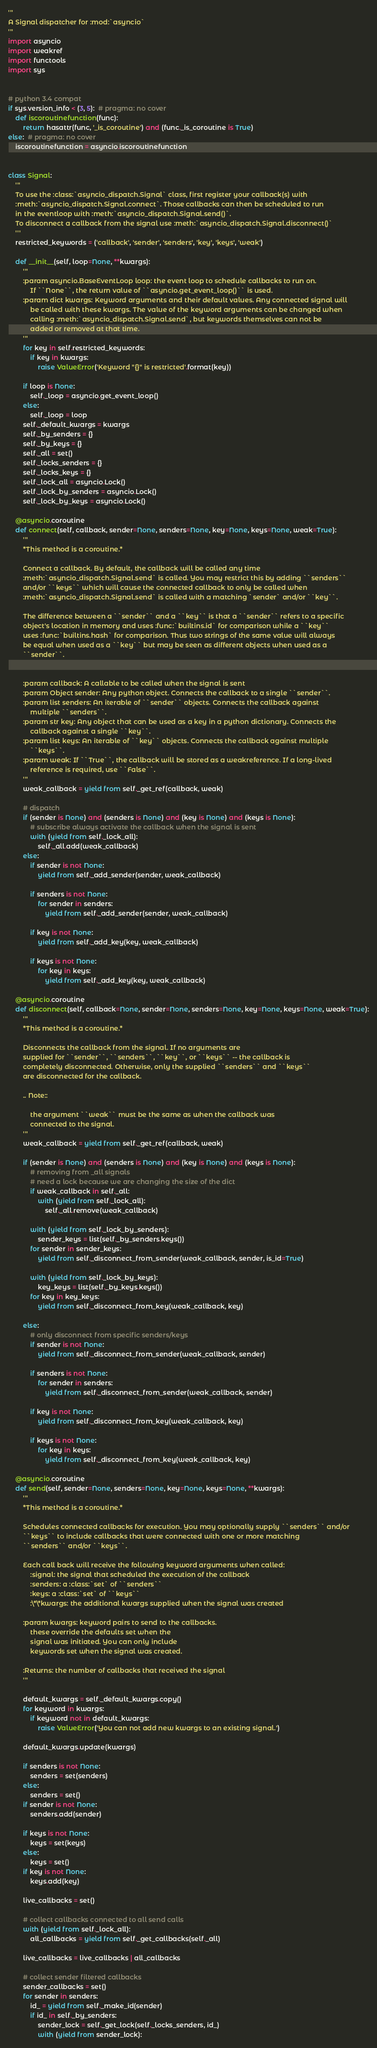<code> <loc_0><loc_0><loc_500><loc_500><_Python_>'''
A Signal dispatcher for :mod:`asyncio`
'''
import asyncio
import weakref
import functools
import sys


# python 3.4 compat
if sys.version_info < (3, 5):  # pragma: no cover
    def iscoroutinefunction(func):
        return hasattr(func, '_is_coroutine') and (func._is_coroutine is True)
else:  # pragma: no cover
    iscoroutinefunction = asyncio.iscoroutinefunction


class Signal:
    '''
    To use the :class:`asyncio_dispatch.Signal` class, first register your callback(s) with
    :meth:`asyncio_dispatch.Signal.connect`. Those callbacks can then be scheduled to run
    in the eventloop with :meth:`asyncio_dispatch.Signal.send()`.
    To disconnect a callback from the signal use :meth:`asyncio_dispatch.Signal.disconnect()`
    '''
    restricted_keywords = ('callback', 'sender', 'senders', 'key', 'keys', 'weak')

    def __init__(self, loop=None, **kwargs):
        '''
        :param asyncio.BaseEventLoop loop: the event loop to schedule callbacks to run on.
            If ``None``, the return value of ``asyncio.get_event_loop()`` is used.
        :param dict kwargs: Keyword arguments and their default values. Any connected signal will
            be called with these kwargs. The value of the keyword arguments can be changed when
            calling :meth:`asyncio_dispatch.Signal.send`, but keywords themselves can not be
            added or removed at that time.
        '''
        for key in self.restricted_keywords:
            if key in kwargs:
                raise ValueError('Keyword "{}" is restricted'.format(key))

        if loop is None:
            self._loop = asyncio.get_event_loop()
        else:
            self._loop = loop
        self._default_kwargs = kwargs
        self._by_senders = {}
        self._by_keys = {}
        self._all = set()
        self._locks_senders = {}
        self._locks_keys = {}
        self._lock_all = asyncio.Lock()
        self._lock_by_senders = asyncio.Lock()
        self._lock_by_keys = asyncio.Lock()

    @asyncio.coroutine
    def connect(self, callback, sender=None, senders=None, key=None, keys=None, weak=True):
        '''
        *This method is a coroutine.*

        Connect a callback. By default, the callback will be called any time
        :meth:`asyncio_dispatch.Signal.send` is called. You may restrict this by adding ``senders``
        and/or ``keys`` which will cause the connected callback to only be called when
        :meth:`asyncio_dispatch.Signal.send` is called with a matching `sender` and/or ``key``.

        The difference between a ``sender`` and a ``key`` is that a ``sender`` refers to a specific
        object's location in memory and uses :func:`builtins.id` for comparison while a ``key``
        uses :func:`builtins.hash` for comparison. Thus two strings of the same value will always
        be equal when used as a ``key`` but may be seen as different objects when used as a
        ``sender``.


        :param callback: A callable to be called when the signal is sent
        :param Object sender: Any python object. Connects the callback to a single ``sender``.
        :param list senders: An iterable of ``sender`` objects. Connects the callback against
            multiple ``senders``.
        :param str key: Any object that can be used as a key in a python dictionary. Connects the
            callback against a single ``key``.
        :param list keys: An iterable of ``key`` objects. Connects the callback against multiple
            ``keys``.
        :param weak: If ``True``, the callback will be stored as a weakreference. If a long-lived
            reference is required, use ``False``.
        '''
        weak_callback = yield from self._get_ref(callback, weak)

        # dispatch
        if (sender is None) and (senders is None) and (key is None) and (keys is None):
            # subscribe always activate the callback when the signal is sent
            with (yield from self._lock_all):
                self._all.add(weak_callback)
        else:
            if sender is not None:
                yield from self._add_sender(sender, weak_callback)

            if senders is not None:
                for sender in senders:
                    yield from self._add_sender(sender, weak_callback)

            if key is not None:
                yield from self._add_key(key, weak_callback)

            if keys is not None:
                for key in keys:
                    yield from self._add_key(key, weak_callback)

    @asyncio.coroutine
    def disconnect(self, callback=None, sender=None, senders=None, key=None, keys=None, weak=True):
        '''
        *This method is a coroutine.*

        Disconnects the callback from the signal. If no arguments are
        supplied for ``sender``, ``senders``, ``key``, or ``keys`` -- the callback is
        completely disconnected. Otherwise, only the supplied ``senders`` and ``keys``
        are disconnected for the callback.

        .. Note::

            the argument ``weak`` must be the same as when the callback was
            connected to the signal.
        '''
        weak_callback = yield from self._get_ref(callback, weak)

        if (sender is None) and (senders is None) and (key is None) and (keys is None):
            # removing from _all signals
            # need a lock because we are changing the size of the dict
            if weak_callback in self._all:
                with (yield from self._lock_all):
                    self._all.remove(weak_callback)

            with (yield from self._lock_by_senders):
                sender_keys = list(self._by_senders.keys())
            for sender in sender_keys:
                yield from self._disconnect_from_sender(weak_callback, sender, is_id=True)

            with (yield from self._lock_by_keys):
                key_keys = list(self._by_keys.keys())
            for key in key_keys:
                yield from self._disconnect_from_key(weak_callback, key)

        else:
            # only disconnect from specific senders/keys
            if sender is not None:
                yield from self._disconnect_from_sender(weak_callback, sender)

            if senders is not None:
                for sender in senders:
                    yield from self._disconnect_from_sender(weak_callback, sender)

            if key is not None:
                yield from self._disconnect_from_key(weak_callback, key)

            if keys is not None:
                for key in keys:
                    yield from self._disconnect_from_key(weak_callback, key)

    @asyncio.coroutine
    def send(self, sender=None, senders=None, key=None, keys=None, **kwargs):
        '''
        *This method is a coroutine.*

        Schedules connected callbacks for execution. You may optionally supply ``senders`` and/or
        ``keys`` to include callbacks that were connected with one or more matching
        ``senders`` and/or ``keys``.

        Each call back will receive the following keyword arguments when called:
            :signal: the signal that scheduled the execution of the callback
            :senders: a :class:`set` of ``senders``
            :keys: a :class:`set` of ``keys``
            :\*\*kwargs: the additional kwargs supplied when the signal was created

        :param kwargs: keyword pairs to send to the callbacks.
            these override the defaults set when the
            signal was initiated. You can only include
            keywords set when the signal was created.

        :Returns: the number of callbacks that received the signal
        '''

        default_kwargs = self._default_kwargs.copy()
        for keyword in kwargs:
            if keyword not in default_kwargs:
                raise ValueError('You can not add new kwargs to an existing signal.')

        default_kwargs.update(kwargs)

        if senders is not None:
            senders = set(senders)
        else:
            senders = set()
        if sender is not None:
            senders.add(sender)

        if keys is not None:
            keys = set(keys)
        else:
            keys = set()
        if key is not None:
            keys.add(key)

        live_callbacks = set()

        # collect callbacks connected to all send calls
        with (yield from self._lock_all):
            all_callbacks = yield from self._get_callbacks(self._all)

        live_callbacks = live_callbacks | all_callbacks

        # collect sender filtered callbacks
        sender_callbacks = set()
        for sender in senders:
            id_ = yield from self._make_id(sender)
            if id_ in self._by_senders:
                sender_lock = self._get_lock(self._locks_senders, id_)
                with (yield from sender_lock):</code> 